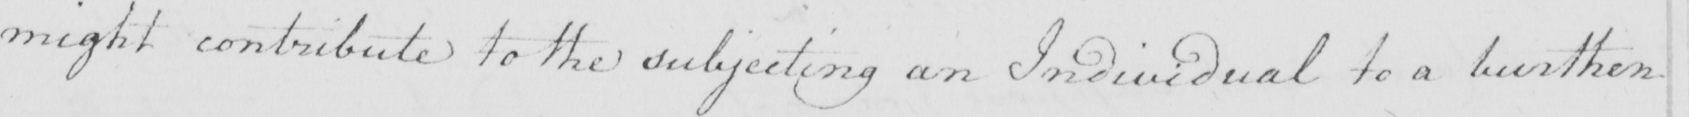Can you tell me what this handwritten text says? might contribute to the subjecting an Individual to a burthen 